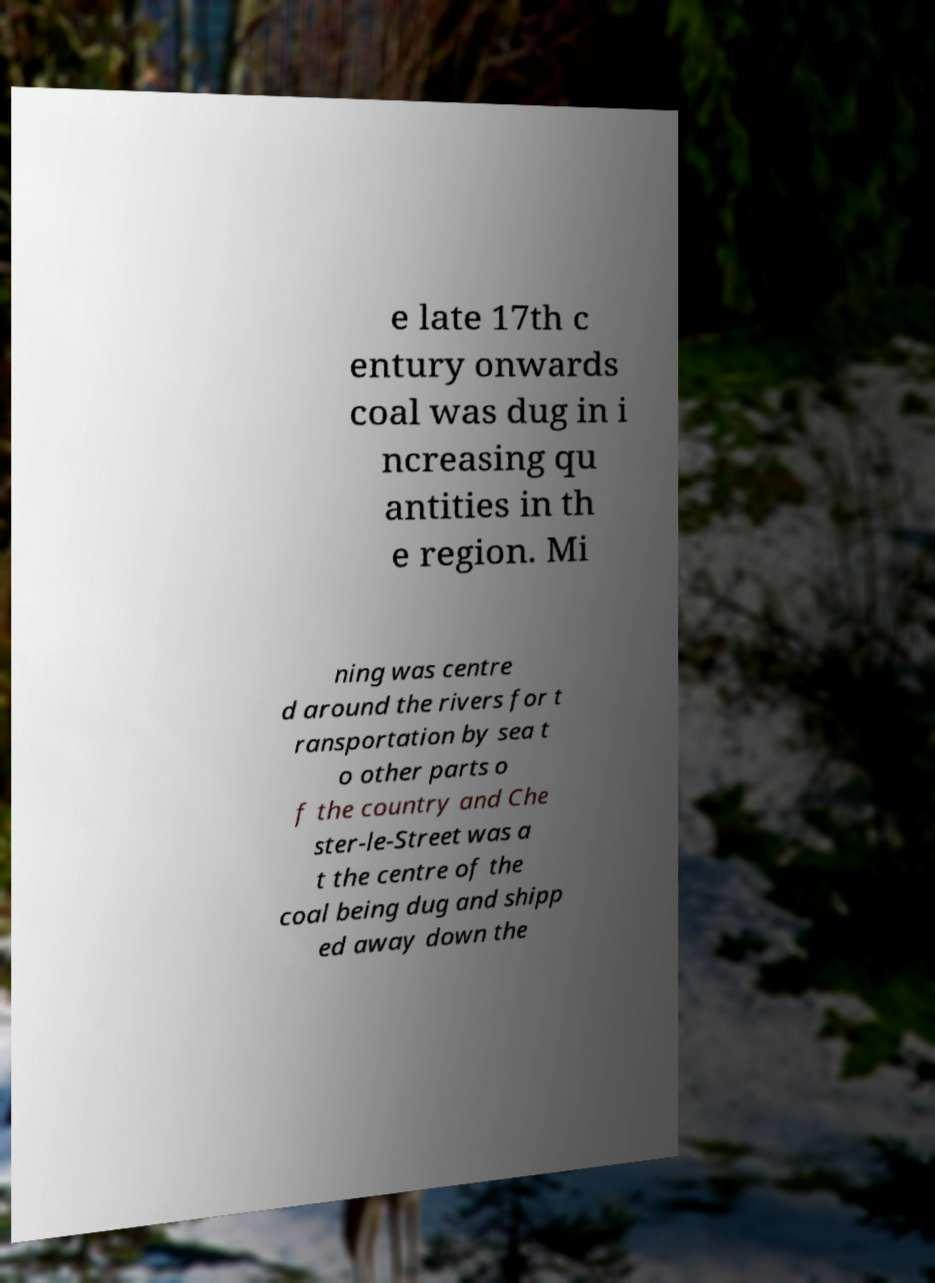Can you read and provide the text displayed in the image?This photo seems to have some interesting text. Can you extract and type it out for me? e late 17th c entury onwards coal was dug in i ncreasing qu antities in th e region. Mi ning was centre d around the rivers for t ransportation by sea t o other parts o f the country and Che ster-le-Street was a t the centre of the coal being dug and shipp ed away down the 